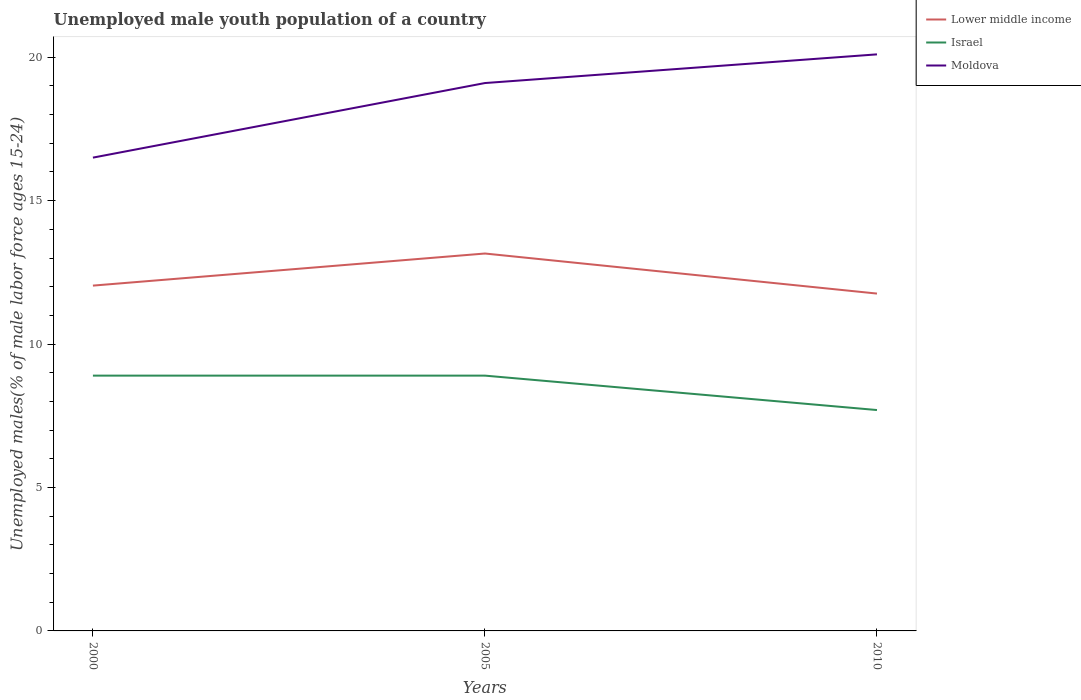How many different coloured lines are there?
Provide a short and direct response. 3. Is the number of lines equal to the number of legend labels?
Offer a terse response. Yes. Across all years, what is the maximum percentage of unemployed male youth population in Lower middle income?
Offer a very short reply. 11.76. In which year was the percentage of unemployed male youth population in Israel maximum?
Your answer should be compact. 2010. What is the total percentage of unemployed male youth population in Moldova in the graph?
Provide a succinct answer. -2.6. What is the difference between the highest and the second highest percentage of unemployed male youth population in Lower middle income?
Offer a terse response. 1.4. Is the percentage of unemployed male youth population in Lower middle income strictly greater than the percentage of unemployed male youth population in Israel over the years?
Your answer should be compact. No. How many lines are there?
Give a very brief answer. 3. What is the difference between two consecutive major ticks on the Y-axis?
Give a very brief answer. 5. Are the values on the major ticks of Y-axis written in scientific E-notation?
Provide a short and direct response. No. Does the graph contain any zero values?
Give a very brief answer. No. How many legend labels are there?
Provide a succinct answer. 3. What is the title of the graph?
Give a very brief answer. Unemployed male youth population of a country. What is the label or title of the X-axis?
Your answer should be compact. Years. What is the label or title of the Y-axis?
Offer a very short reply. Unemployed males(% of male labor force ages 15-24). What is the Unemployed males(% of male labor force ages 15-24) of Lower middle income in 2000?
Your answer should be compact. 12.04. What is the Unemployed males(% of male labor force ages 15-24) of Israel in 2000?
Offer a terse response. 8.9. What is the Unemployed males(% of male labor force ages 15-24) of Moldova in 2000?
Your answer should be compact. 16.5. What is the Unemployed males(% of male labor force ages 15-24) in Lower middle income in 2005?
Your answer should be very brief. 13.16. What is the Unemployed males(% of male labor force ages 15-24) of Israel in 2005?
Your response must be concise. 8.9. What is the Unemployed males(% of male labor force ages 15-24) in Moldova in 2005?
Offer a very short reply. 19.1. What is the Unemployed males(% of male labor force ages 15-24) of Lower middle income in 2010?
Keep it short and to the point. 11.76. What is the Unemployed males(% of male labor force ages 15-24) of Israel in 2010?
Ensure brevity in your answer.  7.7. What is the Unemployed males(% of male labor force ages 15-24) of Moldova in 2010?
Provide a succinct answer. 20.1. Across all years, what is the maximum Unemployed males(% of male labor force ages 15-24) in Lower middle income?
Your answer should be very brief. 13.16. Across all years, what is the maximum Unemployed males(% of male labor force ages 15-24) in Israel?
Offer a terse response. 8.9. Across all years, what is the maximum Unemployed males(% of male labor force ages 15-24) in Moldova?
Provide a succinct answer. 20.1. Across all years, what is the minimum Unemployed males(% of male labor force ages 15-24) of Lower middle income?
Provide a short and direct response. 11.76. Across all years, what is the minimum Unemployed males(% of male labor force ages 15-24) of Israel?
Ensure brevity in your answer.  7.7. Across all years, what is the minimum Unemployed males(% of male labor force ages 15-24) of Moldova?
Your response must be concise. 16.5. What is the total Unemployed males(% of male labor force ages 15-24) of Lower middle income in the graph?
Offer a terse response. 36.96. What is the total Unemployed males(% of male labor force ages 15-24) in Israel in the graph?
Keep it short and to the point. 25.5. What is the total Unemployed males(% of male labor force ages 15-24) of Moldova in the graph?
Offer a terse response. 55.7. What is the difference between the Unemployed males(% of male labor force ages 15-24) in Lower middle income in 2000 and that in 2005?
Your answer should be very brief. -1.12. What is the difference between the Unemployed males(% of male labor force ages 15-24) of Moldova in 2000 and that in 2005?
Offer a terse response. -2.6. What is the difference between the Unemployed males(% of male labor force ages 15-24) in Lower middle income in 2000 and that in 2010?
Make the answer very short. 0.28. What is the difference between the Unemployed males(% of male labor force ages 15-24) of Lower middle income in 2005 and that in 2010?
Provide a succinct answer. 1.4. What is the difference between the Unemployed males(% of male labor force ages 15-24) of Israel in 2005 and that in 2010?
Your answer should be very brief. 1.2. What is the difference between the Unemployed males(% of male labor force ages 15-24) of Lower middle income in 2000 and the Unemployed males(% of male labor force ages 15-24) of Israel in 2005?
Offer a very short reply. 3.14. What is the difference between the Unemployed males(% of male labor force ages 15-24) of Lower middle income in 2000 and the Unemployed males(% of male labor force ages 15-24) of Moldova in 2005?
Your answer should be very brief. -7.06. What is the difference between the Unemployed males(% of male labor force ages 15-24) of Israel in 2000 and the Unemployed males(% of male labor force ages 15-24) of Moldova in 2005?
Provide a succinct answer. -10.2. What is the difference between the Unemployed males(% of male labor force ages 15-24) of Lower middle income in 2000 and the Unemployed males(% of male labor force ages 15-24) of Israel in 2010?
Make the answer very short. 4.34. What is the difference between the Unemployed males(% of male labor force ages 15-24) of Lower middle income in 2000 and the Unemployed males(% of male labor force ages 15-24) of Moldova in 2010?
Provide a short and direct response. -8.06. What is the difference between the Unemployed males(% of male labor force ages 15-24) of Lower middle income in 2005 and the Unemployed males(% of male labor force ages 15-24) of Israel in 2010?
Provide a succinct answer. 5.46. What is the difference between the Unemployed males(% of male labor force ages 15-24) in Lower middle income in 2005 and the Unemployed males(% of male labor force ages 15-24) in Moldova in 2010?
Make the answer very short. -6.94. What is the difference between the Unemployed males(% of male labor force ages 15-24) of Israel in 2005 and the Unemployed males(% of male labor force ages 15-24) of Moldova in 2010?
Provide a short and direct response. -11.2. What is the average Unemployed males(% of male labor force ages 15-24) of Lower middle income per year?
Offer a very short reply. 12.32. What is the average Unemployed males(% of male labor force ages 15-24) of Moldova per year?
Provide a succinct answer. 18.57. In the year 2000, what is the difference between the Unemployed males(% of male labor force ages 15-24) in Lower middle income and Unemployed males(% of male labor force ages 15-24) in Israel?
Make the answer very short. 3.14. In the year 2000, what is the difference between the Unemployed males(% of male labor force ages 15-24) of Lower middle income and Unemployed males(% of male labor force ages 15-24) of Moldova?
Offer a very short reply. -4.46. In the year 2005, what is the difference between the Unemployed males(% of male labor force ages 15-24) in Lower middle income and Unemployed males(% of male labor force ages 15-24) in Israel?
Provide a short and direct response. 4.26. In the year 2005, what is the difference between the Unemployed males(% of male labor force ages 15-24) in Lower middle income and Unemployed males(% of male labor force ages 15-24) in Moldova?
Provide a short and direct response. -5.94. In the year 2010, what is the difference between the Unemployed males(% of male labor force ages 15-24) of Lower middle income and Unemployed males(% of male labor force ages 15-24) of Israel?
Your answer should be very brief. 4.06. In the year 2010, what is the difference between the Unemployed males(% of male labor force ages 15-24) in Lower middle income and Unemployed males(% of male labor force ages 15-24) in Moldova?
Give a very brief answer. -8.34. In the year 2010, what is the difference between the Unemployed males(% of male labor force ages 15-24) in Israel and Unemployed males(% of male labor force ages 15-24) in Moldova?
Make the answer very short. -12.4. What is the ratio of the Unemployed males(% of male labor force ages 15-24) in Lower middle income in 2000 to that in 2005?
Keep it short and to the point. 0.92. What is the ratio of the Unemployed males(% of male labor force ages 15-24) in Moldova in 2000 to that in 2005?
Your answer should be compact. 0.86. What is the ratio of the Unemployed males(% of male labor force ages 15-24) of Lower middle income in 2000 to that in 2010?
Your response must be concise. 1.02. What is the ratio of the Unemployed males(% of male labor force ages 15-24) in Israel in 2000 to that in 2010?
Make the answer very short. 1.16. What is the ratio of the Unemployed males(% of male labor force ages 15-24) in Moldova in 2000 to that in 2010?
Ensure brevity in your answer.  0.82. What is the ratio of the Unemployed males(% of male labor force ages 15-24) of Lower middle income in 2005 to that in 2010?
Provide a short and direct response. 1.12. What is the ratio of the Unemployed males(% of male labor force ages 15-24) of Israel in 2005 to that in 2010?
Offer a very short reply. 1.16. What is the ratio of the Unemployed males(% of male labor force ages 15-24) of Moldova in 2005 to that in 2010?
Offer a very short reply. 0.95. What is the difference between the highest and the second highest Unemployed males(% of male labor force ages 15-24) in Lower middle income?
Your answer should be compact. 1.12. What is the difference between the highest and the second highest Unemployed males(% of male labor force ages 15-24) in Israel?
Your answer should be compact. 0. What is the difference between the highest and the second highest Unemployed males(% of male labor force ages 15-24) in Moldova?
Make the answer very short. 1. What is the difference between the highest and the lowest Unemployed males(% of male labor force ages 15-24) in Lower middle income?
Keep it short and to the point. 1.4. What is the difference between the highest and the lowest Unemployed males(% of male labor force ages 15-24) of Israel?
Offer a terse response. 1.2. 